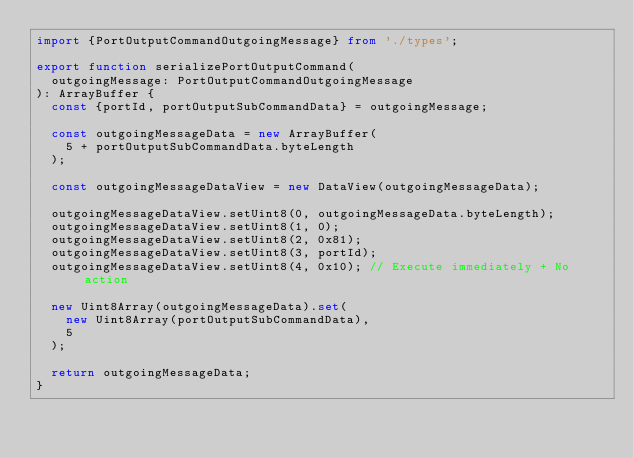<code> <loc_0><loc_0><loc_500><loc_500><_TypeScript_>import {PortOutputCommandOutgoingMessage} from './types';

export function serializePortOutputCommand(
  outgoingMessage: PortOutputCommandOutgoingMessage
): ArrayBuffer {
  const {portId, portOutputSubCommandData} = outgoingMessage;

  const outgoingMessageData = new ArrayBuffer(
    5 + portOutputSubCommandData.byteLength
  );

  const outgoingMessageDataView = new DataView(outgoingMessageData);

  outgoingMessageDataView.setUint8(0, outgoingMessageData.byteLength);
  outgoingMessageDataView.setUint8(1, 0);
  outgoingMessageDataView.setUint8(2, 0x81);
  outgoingMessageDataView.setUint8(3, portId);
  outgoingMessageDataView.setUint8(4, 0x10); // Execute immediately + No action

  new Uint8Array(outgoingMessageData).set(
    new Uint8Array(portOutputSubCommandData),
    5
  );

  return outgoingMessageData;
}
</code> 